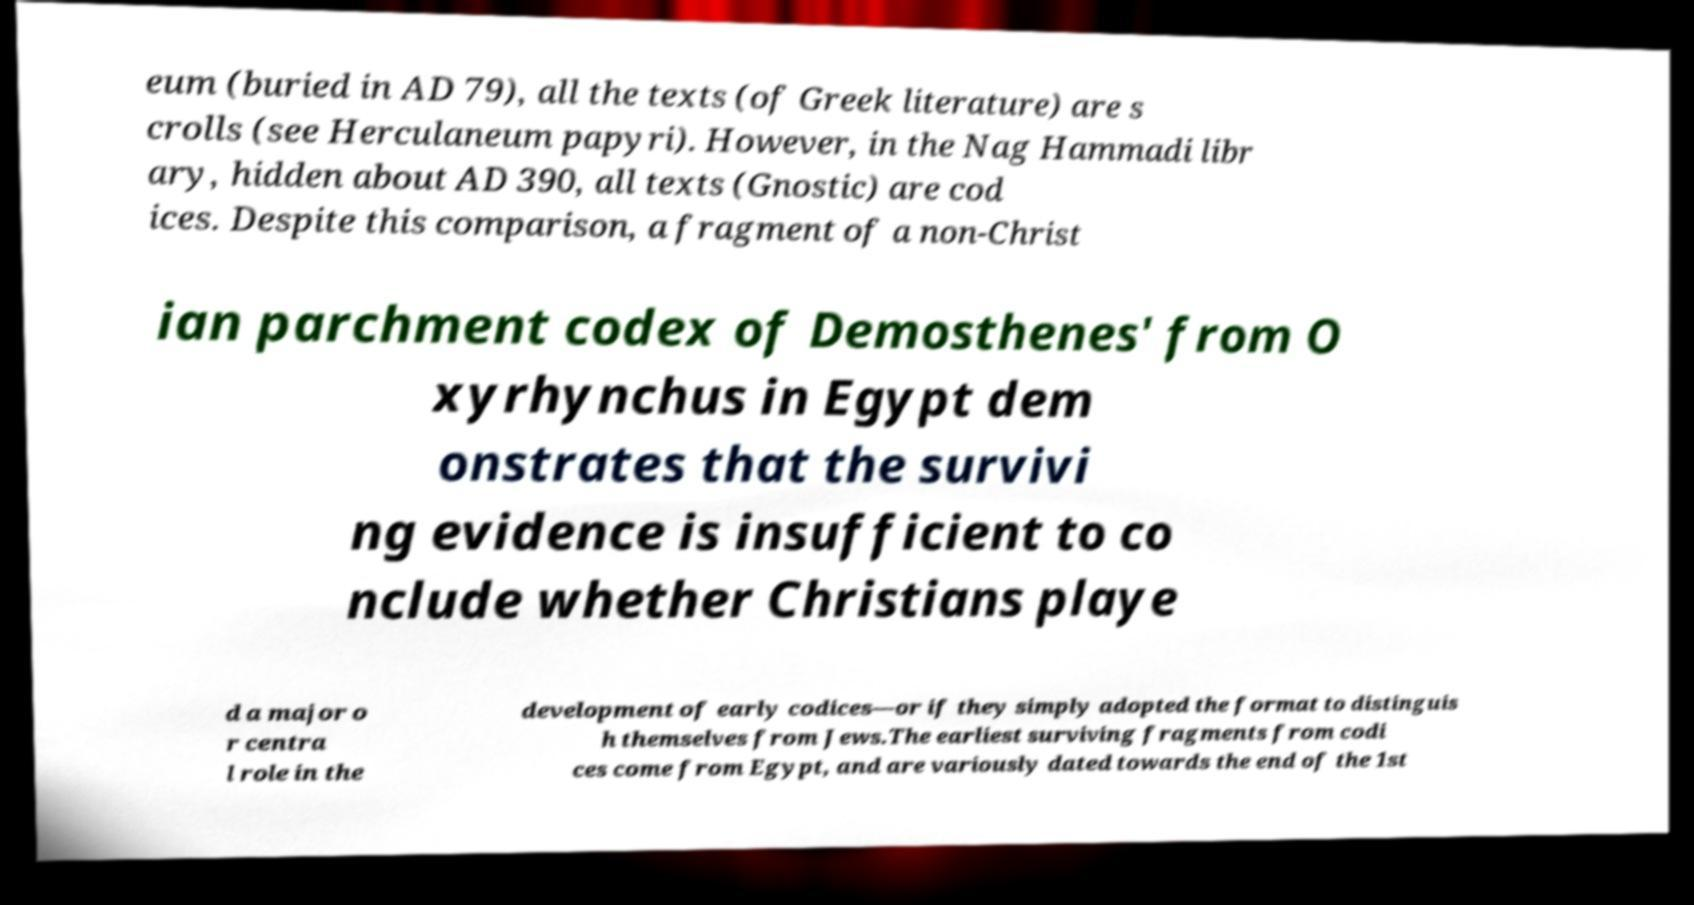Could you assist in decoding the text presented in this image and type it out clearly? eum (buried in AD 79), all the texts (of Greek literature) are s crolls (see Herculaneum papyri). However, in the Nag Hammadi libr ary, hidden about AD 390, all texts (Gnostic) are cod ices. Despite this comparison, a fragment of a non-Christ ian parchment codex of Demosthenes' from O xyrhynchus in Egypt dem onstrates that the survivi ng evidence is insufficient to co nclude whether Christians playe d a major o r centra l role in the development of early codices—or if they simply adopted the format to distinguis h themselves from Jews.The earliest surviving fragments from codi ces come from Egypt, and are variously dated towards the end of the 1st 